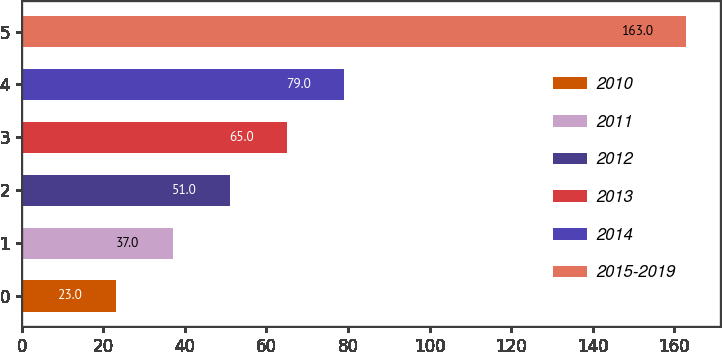Convert chart. <chart><loc_0><loc_0><loc_500><loc_500><bar_chart><fcel>2010<fcel>2011<fcel>2012<fcel>2013<fcel>2014<fcel>2015-2019<nl><fcel>23<fcel>37<fcel>51<fcel>65<fcel>79<fcel>163<nl></chart> 